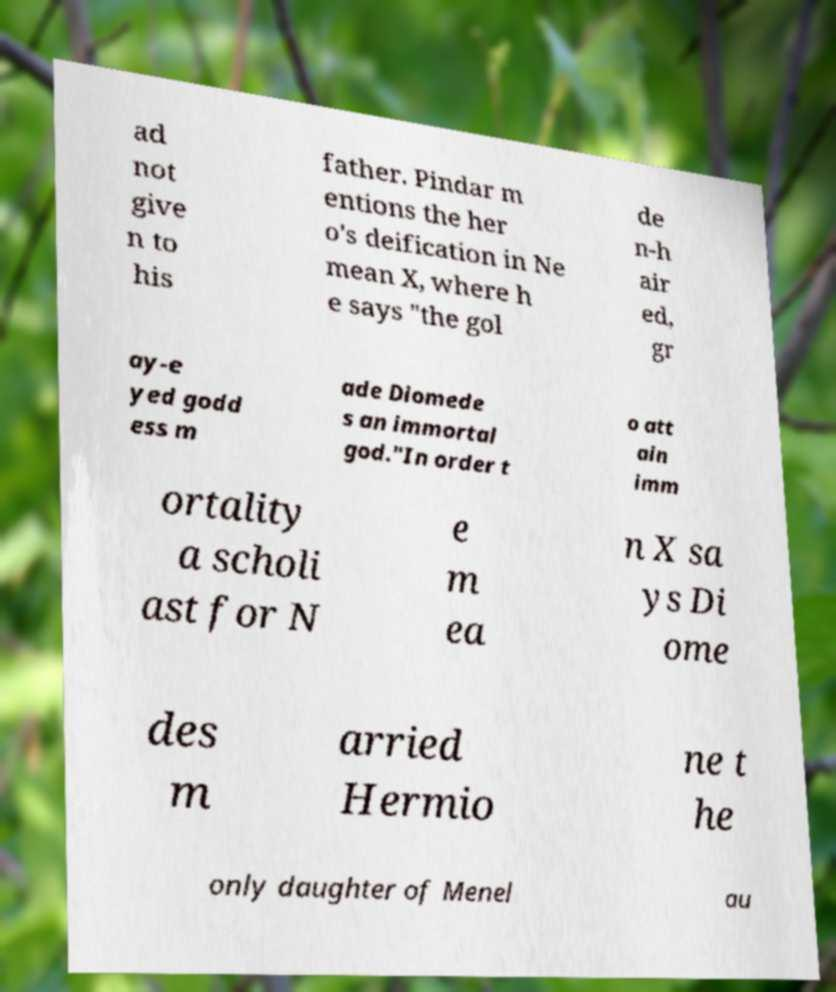Could you assist in decoding the text presented in this image and type it out clearly? ad not give n to his father. Pindar m entions the her o's deification in Ne mean X, where h e says "the gol de n-h air ed, gr ay-e yed godd ess m ade Diomede s an immortal god."In order t o att ain imm ortality a scholi ast for N e m ea n X sa ys Di ome des m arried Hermio ne t he only daughter of Menel au 